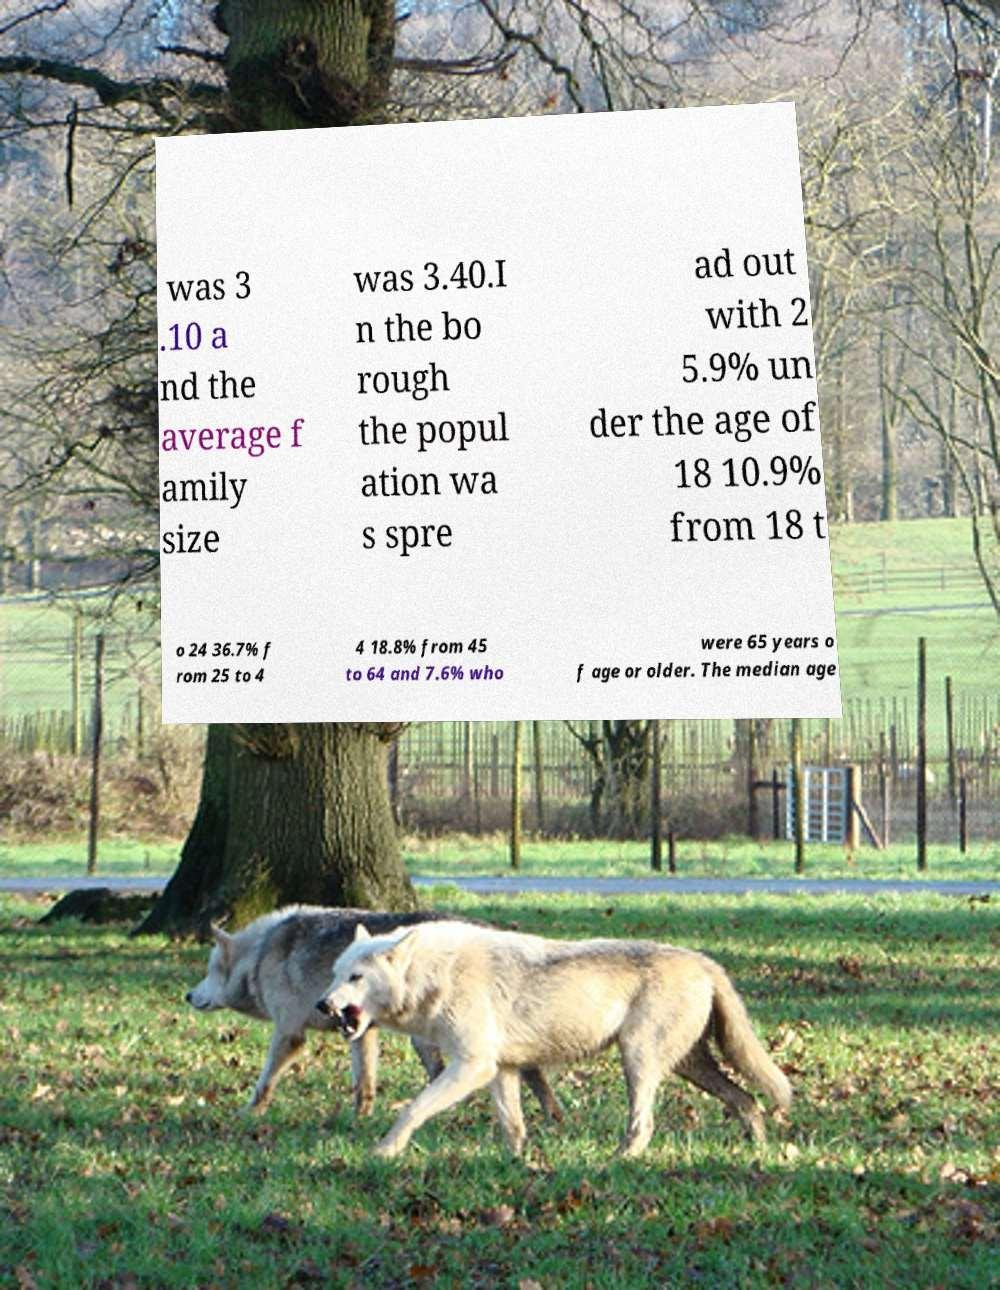Can you read and provide the text displayed in the image?This photo seems to have some interesting text. Can you extract and type it out for me? was 3 .10 a nd the average f amily size was 3.40.I n the bo rough the popul ation wa s spre ad out with 2 5.9% un der the age of 18 10.9% from 18 t o 24 36.7% f rom 25 to 4 4 18.8% from 45 to 64 and 7.6% who were 65 years o f age or older. The median age 